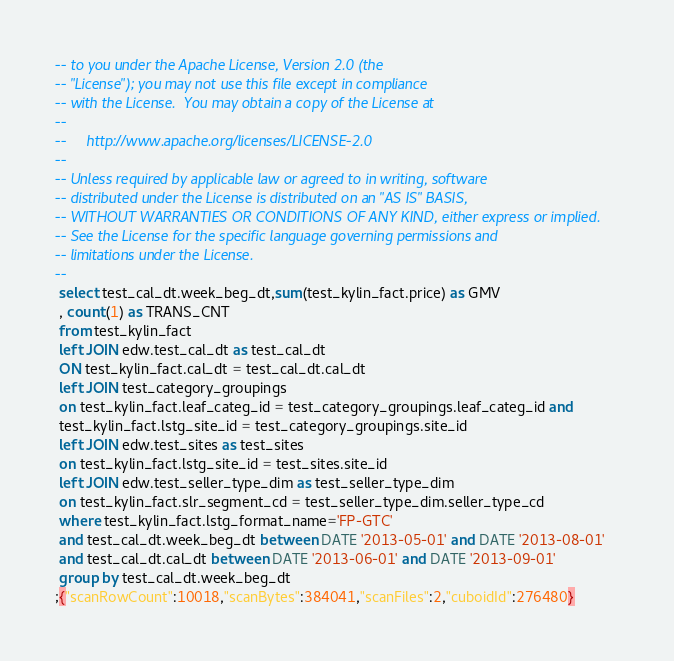<code> <loc_0><loc_0><loc_500><loc_500><_SQL_>-- to you under the Apache License, Version 2.0 (the
-- "License"); you may not use this file except in compliance
-- with the License.  You may obtain a copy of the License at
--
--     http://www.apache.org/licenses/LICENSE-2.0
--
-- Unless required by applicable law or agreed to in writing, software
-- distributed under the License is distributed on an "AS IS" BASIS,
-- WITHOUT WARRANTIES OR CONDITIONS OF ANY KIND, either express or implied.
-- See the License for the specific language governing permissions and
-- limitations under the License.
--
 select test_cal_dt.week_beg_dt,sum(test_kylin_fact.price) as GMV 
 , count(1) as TRANS_CNT
 from test_kylin_fact 
 left JOIN edw.test_cal_dt as test_cal_dt 
 ON test_kylin_fact.cal_dt = test_cal_dt.cal_dt 
 left JOIN test_category_groupings 
 on test_kylin_fact.leaf_categ_id = test_category_groupings.leaf_categ_id and 
 test_kylin_fact.lstg_site_id = test_category_groupings.site_id 
 left JOIN edw.test_sites as test_sites 
 on test_kylin_fact.lstg_site_id = test_sites.site_id 
 left JOIN edw.test_seller_type_dim as test_seller_type_dim 
 on test_kylin_fact.slr_segment_cd = test_seller_type_dim.seller_type_cd 
 where test_kylin_fact.lstg_format_name='FP-GTC' 
 and test_cal_dt.week_beg_dt between DATE '2013-05-01' and DATE '2013-08-01' 
 and test_cal_dt.cal_dt between DATE '2013-06-01' and DATE '2013-09-01' 
 group by test_cal_dt.week_beg_dt
;{"scanRowCount":10018,"scanBytes":384041,"scanFiles":2,"cuboidId":276480}</code> 